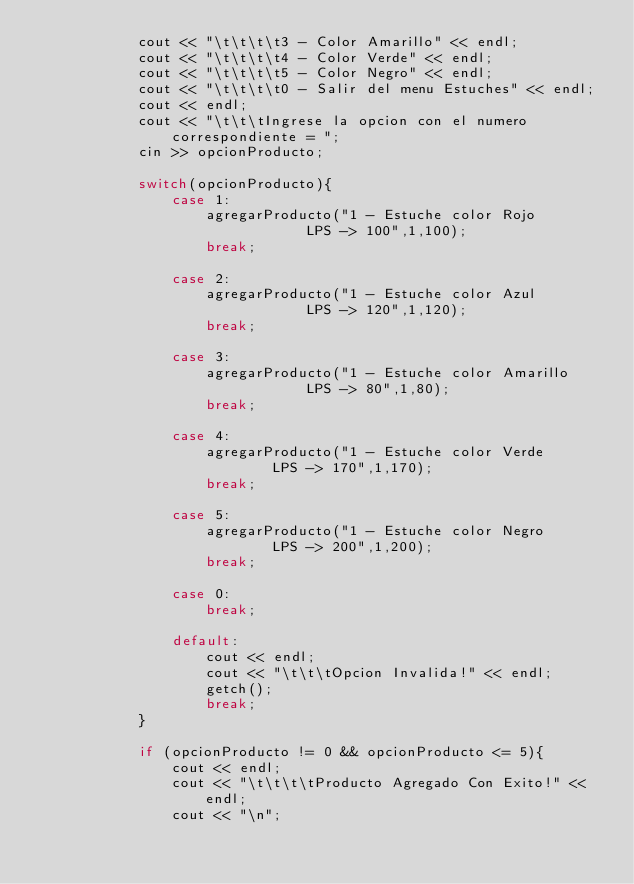<code> <loc_0><loc_0><loc_500><loc_500><_C++_>			cout << "\t\t\t\t3 - Color Amarillo" << endl;
			cout << "\t\t\t\t4 - Color Verde" << endl;
			cout << "\t\t\t\t5 - Color Negro" << endl;
			cout << "\t\t\t\t0 - Salir del menu Estuches" << endl;
			cout << endl;
			cout << "\t\t\tIngrese la opcion con el numero correspondiente = ";
			cin >> opcionProducto;
			
			switch(opcionProducto){
				case 1:
					agregarProducto("1 - Estuche color Rojo 			LPS -> 100",1,100);
					break;
					
				case 2:
					agregarProducto("1 - Estuche color Azul 			LPS -> 120",1,120);
					break;
					
				case 3:
					agregarProducto("1 - Estuche color Amarillo 		LPS -> 80",1,80);
					break;
					
				case 4:
					agregarProducto("1 - Estuche color Verde 		LPS -> 170",1,170);
					break;
					
				case 5:
					agregarProducto("1 - Estuche color Negro 		LPS -> 200",1,200);
					break;
					
				case 0:
					break;	
					
				default:
					cout << endl;
					cout << "\t\t\tOpcion Invalida!" << endl;
					getch();
					break;						
			}
			
			if (opcionProducto != 0 && opcionProducto <= 5){
				cout << endl;
			    cout << "\t\t\t\tProducto Agregado Con Exito!" << endl; 
			    cout << "\n";</code> 